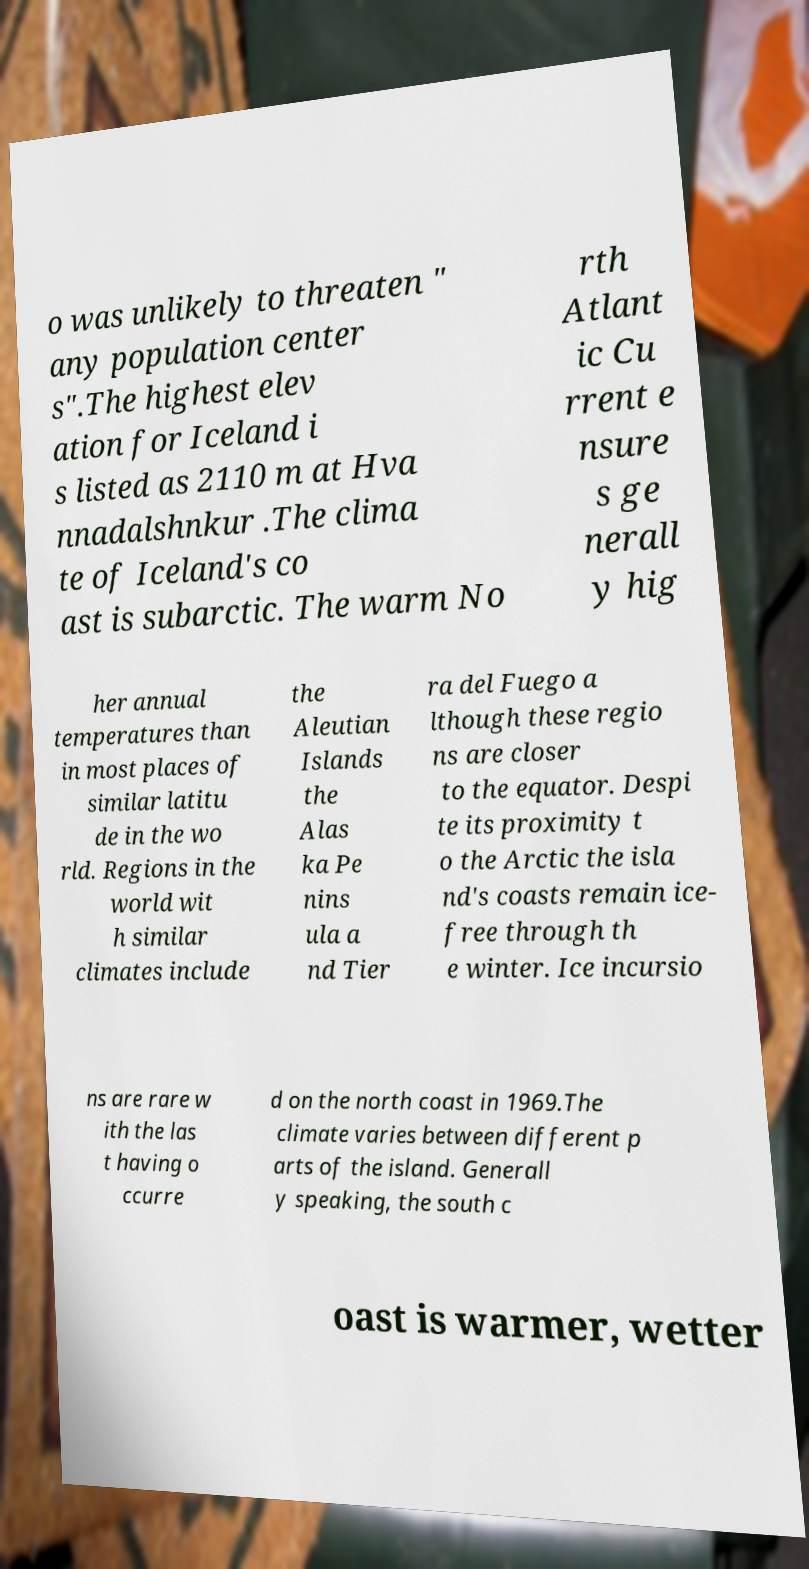Can you read and provide the text displayed in the image?This photo seems to have some interesting text. Can you extract and type it out for me? o was unlikely to threaten " any population center s".The highest elev ation for Iceland i s listed as 2110 m at Hva nnadalshnkur .The clima te of Iceland's co ast is subarctic. The warm No rth Atlant ic Cu rrent e nsure s ge nerall y hig her annual temperatures than in most places of similar latitu de in the wo rld. Regions in the world wit h similar climates include the Aleutian Islands the Alas ka Pe nins ula a nd Tier ra del Fuego a lthough these regio ns are closer to the equator. Despi te its proximity t o the Arctic the isla nd's coasts remain ice- free through th e winter. Ice incursio ns are rare w ith the las t having o ccurre d on the north coast in 1969.The climate varies between different p arts of the island. Generall y speaking, the south c oast is warmer, wetter 